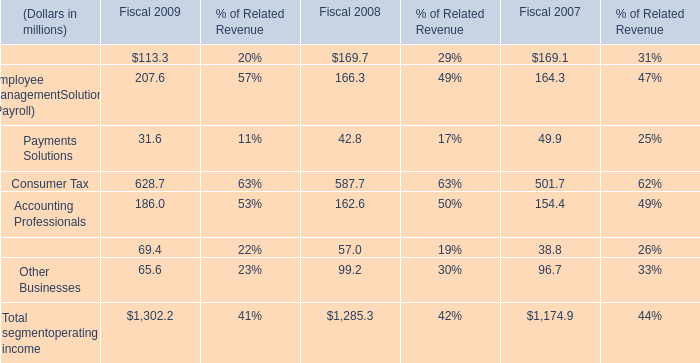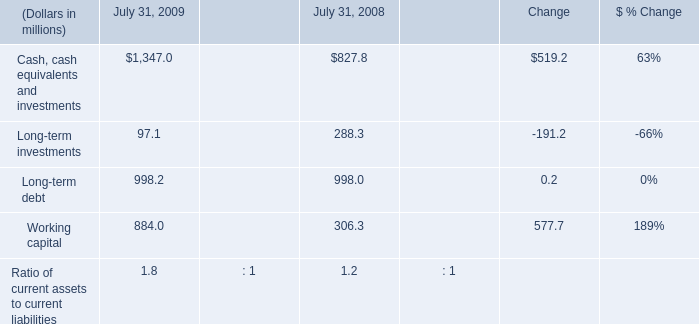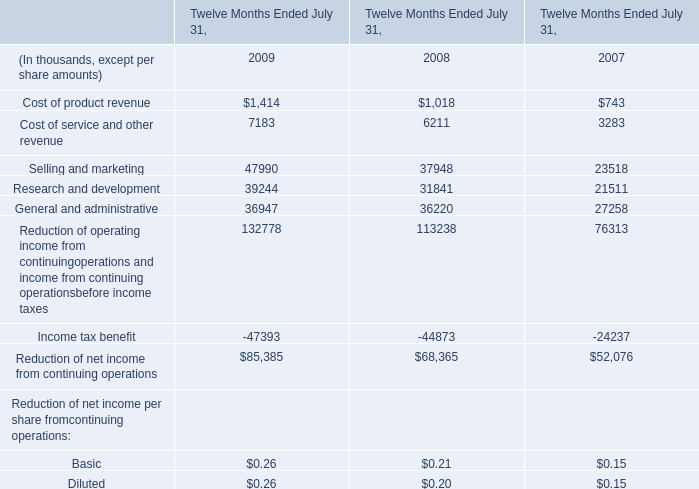What is the total amount of Cash, cash equivalents and investments of July 31, 2009, General and administrative of Twelve Months Ended July 31, 2008, and Reduction of net income from continuing operations of Twelve Months Ended July 31, 2007 ? 
Computations: ((1347.0 + 36220.0) + 52076.0)
Answer: 89643.0. 